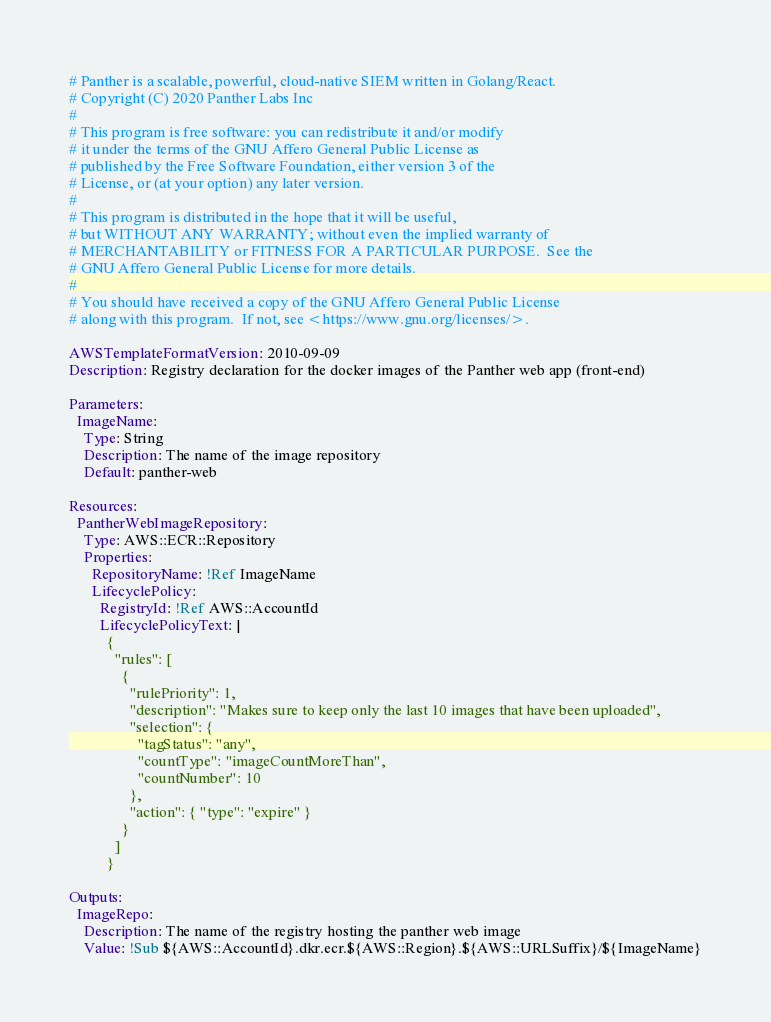Convert code to text. <code><loc_0><loc_0><loc_500><loc_500><_YAML_># Panther is a scalable, powerful, cloud-native SIEM written in Golang/React.
# Copyright (C) 2020 Panther Labs Inc
#
# This program is free software: you can redistribute it and/or modify
# it under the terms of the GNU Affero General Public License as
# published by the Free Software Foundation, either version 3 of the
# License, or (at your option) any later version.
#
# This program is distributed in the hope that it will be useful,
# but WITHOUT ANY WARRANTY; without even the implied warranty of
# MERCHANTABILITY or FITNESS FOR A PARTICULAR PURPOSE.  See the
# GNU Affero General Public License for more details.
#
# You should have received a copy of the GNU Affero General Public License
# along with this program.  If not, see <https://www.gnu.org/licenses/>.

AWSTemplateFormatVersion: 2010-09-09
Description: Registry declaration for the docker images of the Panther web app (front-end)

Parameters:
  ImageName:
    Type: String
    Description: The name of the image repository
    Default: panther-web

Resources:
  PantherWebImageRepository:
    Type: AWS::ECR::Repository
    Properties:
      RepositoryName: !Ref ImageName
      LifecyclePolicy:
        RegistryId: !Ref AWS::AccountId
        LifecyclePolicyText: |
          {
            "rules": [
              {
                "rulePriority": 1,
                "description": "Makes sure to keep only the last 10 images that have been uploaded",
                "selection": {
                  "tagStatus": "any",
                  "countType": "imageCountMoreThan",
                  "countNumber": 10
                },
                "action": { "type": "expire" }
              }
            ]
          }

Outputs:
  ImageRepo:
    Description: The name of the registry hosting the panther web image
    Value: !Sub ${AWS::AccountId}.dkr.ecr.${AWS::Region}.${AWS::URLSuffix}/${ImageName}
</code> 